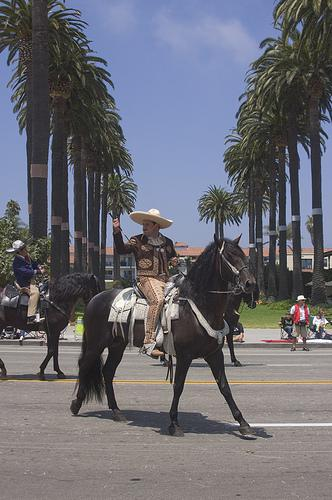Question: what is the man riding?
Choices:
A. An elephant.
B. A camel.
C. A bike.
D. A horse.
Answer with the letter. Answer: D Question: what is the animal called?
Choices:
A. Horse.
B. Zebra.
C. Rhinoceros.
D. Leopard.
Answer with the letter. Answer: A Question: how many horses are there?
Choices:
A. Three.
B. Four.
C. Two.
D. Five.
Answer with the letter. Answer: C Question: why is the man riding a horse?
Choices:
A. Pleasure.
B. Learning.
C. Giving a lesson.
D. Transportation.
Answer with the letter. Answer: D Question: who is riding the horse?
Choices:
A. The man.
B. The woman.
C. The cowboy.
D. The cowgirl.
Answer with the letter. Answer: A 